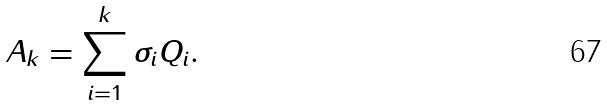<formula> <loc_0><loc_0><loc_500><loc_500>A _ { k } = \sum _ { i = 1 } ^ { k } \sigma _ { i } Q _ { i } .</formula> 